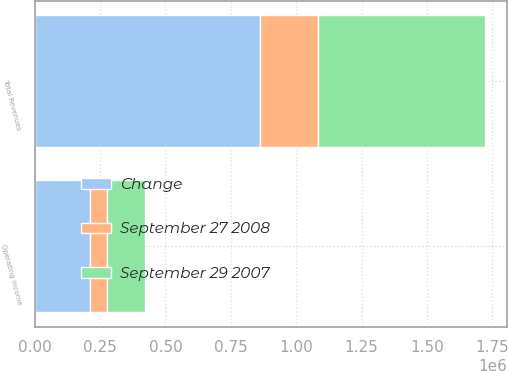Convert chart to OTSL. <chart><loc_0><loc_0><loc_500><loc_500><stacked_bar_chart><ecel><fcel>Total Revenues<fcel>Operating Income<nl><fcel>Change<fcel>860848<fcel>211704<nl><fcel>September 29 2007<fcel>638898<fcel>146907<nl><fcel>September 27 2008<fcel>221950<fcel>64797<nl></chart> 